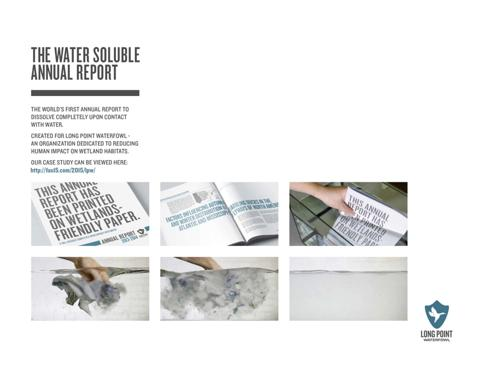What is the unique feature of this annual report mentioned in the image? The annual report's most unique feature, as illustrated in the image, is its water solubility. This means the report is designed to dissolve in water, highlighting its eco-friendly approach to sustainability and its symbolic commitment to impacting wetland conservation positively. 